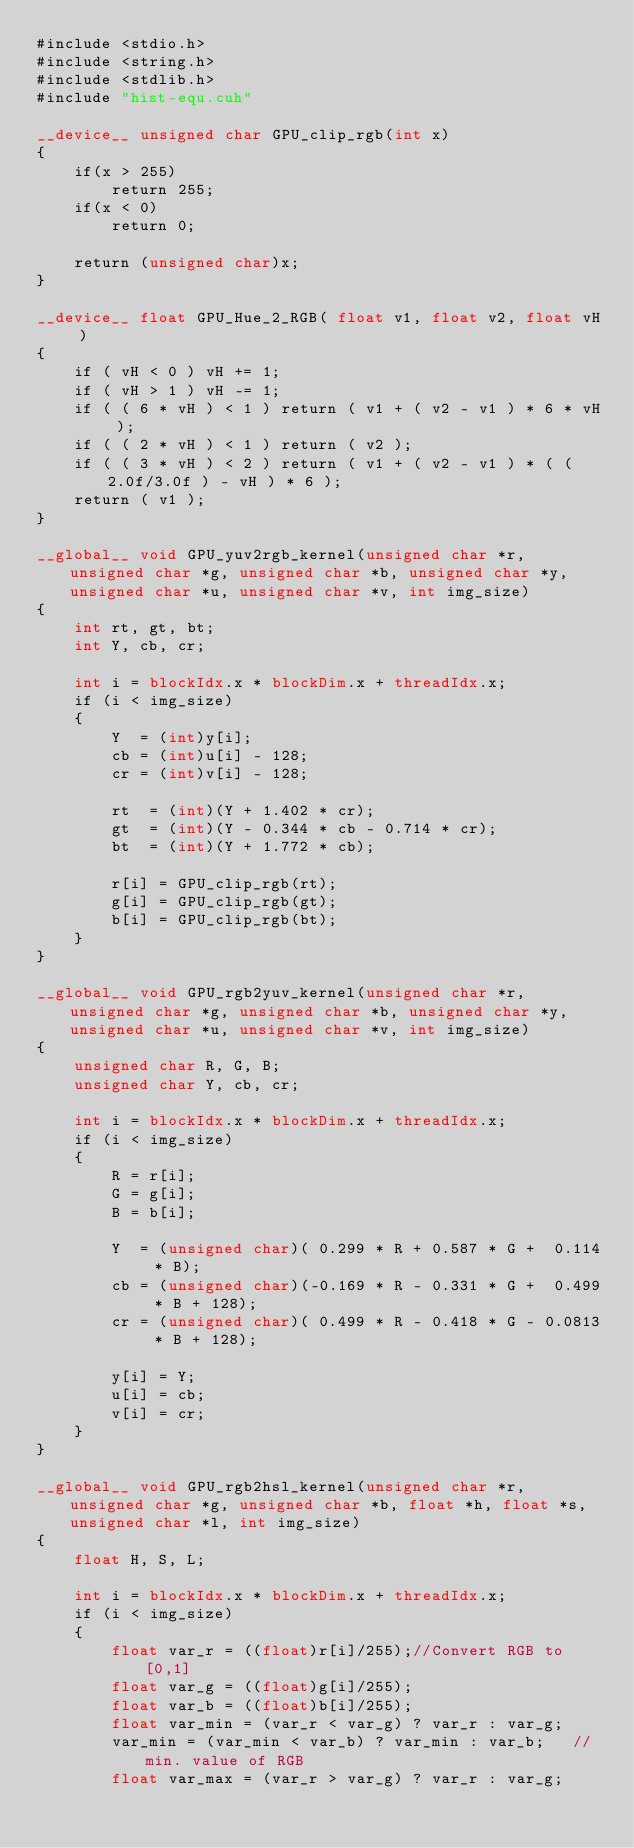<code> <loc_0><loc_0><loc_500><loc_500><_Cuda_>#include <stdio.h>
#include <string.h>
#include <stdlib.h>
#include "hist-equ.cuh"

__device__ unsigned char GPU_clip_rgb(int x)
{
    if(x > 255)
        return 255;
    if(x < 0)
        return 0;

    return (unsigned char)x;
}

__device__ float GPU_Hue_2_RGB( float v1, float v2, float vH )
{
    if ( vH < 0 ) vH += 1;
    if ( vH > 1 ) vH -= 1;
    if ( ( 6 * vH ) < 1 ) return ( v1 + ( v2 - v1 ) * 6 * vH );
    if ( ( 2 * vH ) < 1 ) return ( v2 );
    if ( ( 3 * vH ) < 2 ) return ( v1 + ( v2 - v1 ) * ( ( 2.0f/3.0f ) - vH ) * 6 );
    return ( v1 );
}

__global__ void GPU_yuv2rgb_kernel(unsigned char *r, unsigned char *g, unsigned char *b, unsigned char *y, unsigned char *u, unsigned char *v, int img_size)
{
    int rt, gt, bt;
    int Y, cb, cr;

    int i = blockIdx.x * blockDim.x + threadIdx.x;
    if (i < img_size)
    {
        Y  = (int)y[i];
        cb = (int)u[i] - 128;
        cr = (int)v[i] - 128;
        
        rt  = (int)(Y + 1.402 * cr);
        gt  = (int)(Y - 0.344 * cb - 0.714 * cr);
        bt  = (int)(Y + 1.772 * cb);

        r[i] = GPU_clip_rgb(rt);
        g[i] = GPU_clip_rgb(gt);
        b[i] = GPU_clip_rgb(bt);
    }
}

__global__ void GPU_rgb2yuv_kernel(unsigned char *r, unsigned char *g, unsigned char *b, unsigned char *y, unsigned char *u, unsigned char *v, int img_size)
{
    unsigned char R, G, B;
    unsigned char Y, cb, cr;

    int i = blockIdx.x * blockDim.x + threadIdx.x;
    if (i < img_size)
    {
        R = r[i];
        G = g[i];
        B = b[i];
        
        Y  = (unsigned char)( 0.299 * R + 0.587 * G +  0.114 * B);
        cb = (unsigned char)(-0.169 * R - 0.331 * G +  0.499 * B + 128);
        cr = (unsigned char)( 0.499 * R - 0.418 * G - 0.0813 * B + 128);
        
        y[i] = Y;
        u[i] = cb;
        v[i] = cr;
    }
}

__global__ void GPU_rgb2hsl_kernel(unsigned char *r, unsigned char *g, unsigned char *b, float *h, float *s, unsigned char *l, int img_size)
{
    float H, S, L;

    int i = blockIdx.x * blockDim.x + threadIdx.x;
    if (i < img_size)
    {  
        float var_r = ((float)r[i]/255);//Convert RGB to [0,1]
        float var_g = ((float)g[i]/255);
        float var_b = ((float)b[i]/255);
        float var_min = (var_r < var_g) ? var_r : var_g;
        var_min = (var_min < var_b) ? var_min : var_b;   //min. value of RGB
        float var_max = (var_r > var_g) ? var_r : var_g;</code> 